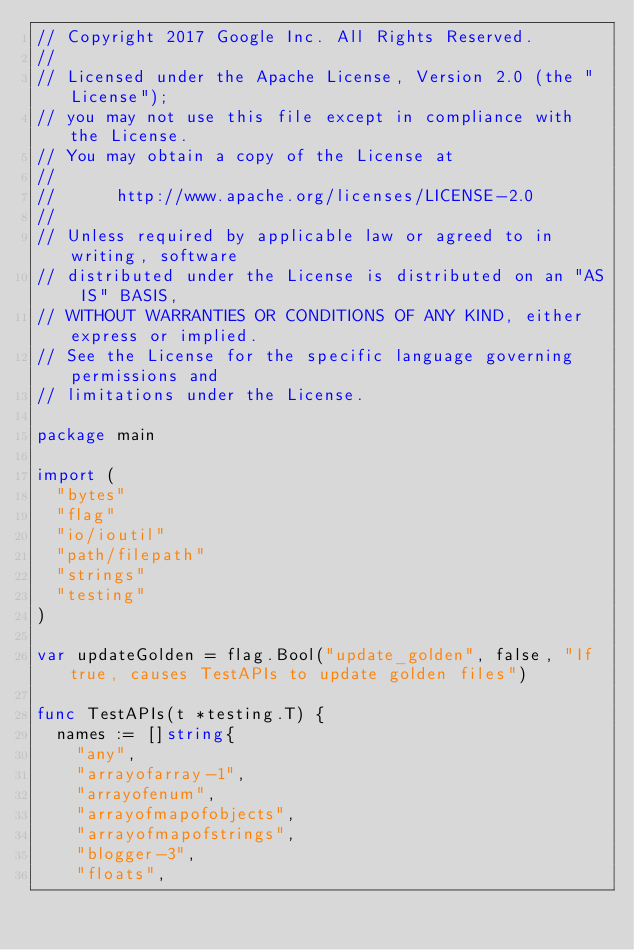<code> <loc_0><loc_0><loc_500><loc_500><_Go_>// Copyright 2017 Google Inc. All Rights Reserved.
//
// Licensed under the Apache License, Version 2.0 (the "License");
// you may not use this file except in compliance with the License.
// You may obtain a copy of the License at
//
//      http://www.apache.org/licenses/LICENSE-2.0
//
// Unless required by applicable law or agreed to in writing, software
// distributed under the License is distributed on an "AS IS" BASIS,
// WITHOUT WARRANTIES OR CONDITIONS OF ANY KIND, either express or implied.
// See the License for the specific language governing permissions and
// limitations under the License.

package main

import (
	"bytes"
	"flag"
	"io/ioutil"
	"path/filepath"
	"strings"
	"testing"
)

var updateGolden = flag.Bool("update_golden", false, "If true, causes TestAPIs to update golden files")

func TestAPIs(t *testing.T) {
	names := []string{
		"any",
		"arrayofarray-1",
		"arrayofenum",
		"arrayofmapofobjects",
		"arrayofmapofstrings",
		"blogger-3",
		"floats",</code> 